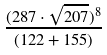<formula> <loc_0><loc_0><loc_500><loc_500>\frac { ( 2 8 7 \cdot \sqrt { 2 0 7 } ) ^ { 8 } } { ( 1 2 2 + 1 5 5 ) }</formula> 